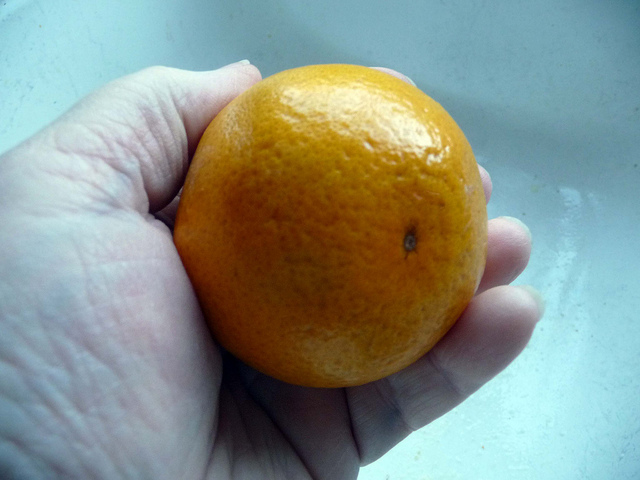<image>Which fruit has dark colored seeds inside? I don't know. It could be any fruit with dark colored seeds such as orange, pomegranate, grapes or apple. Which fruit has dark colored seeds inside? The fruit that has dark colored seeds inside is pomegranate. 